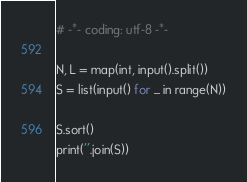Convert code to text. <code><loc_0><loc_0><loc_500><loc_500><_Python_># -*- coding: utf-8 -*-

N, L = map(int, input().split())
S = list(input() for _ in range(N))

S.sort()
print(''.join(S))
</code> 